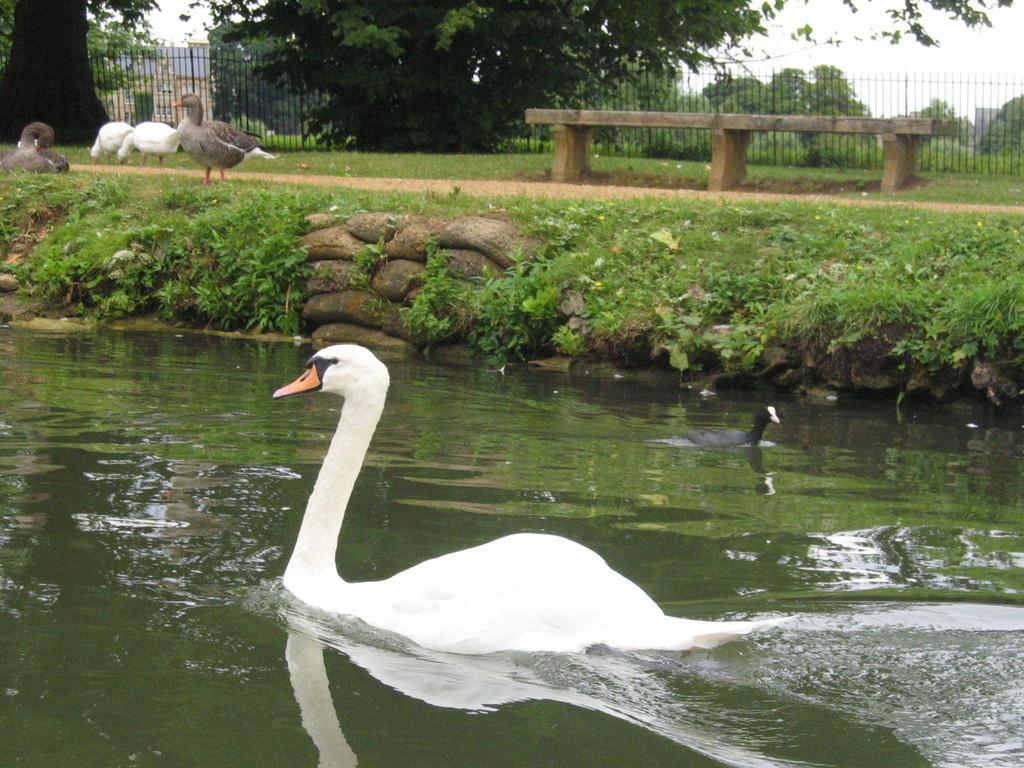Please provide a concise description of this image. In this image in the front there is water and in the water there are birds. In the center there is grass on the ground and in the background there are birds, there is an empty bench, there is a fence and there are trees and there are buildings. 